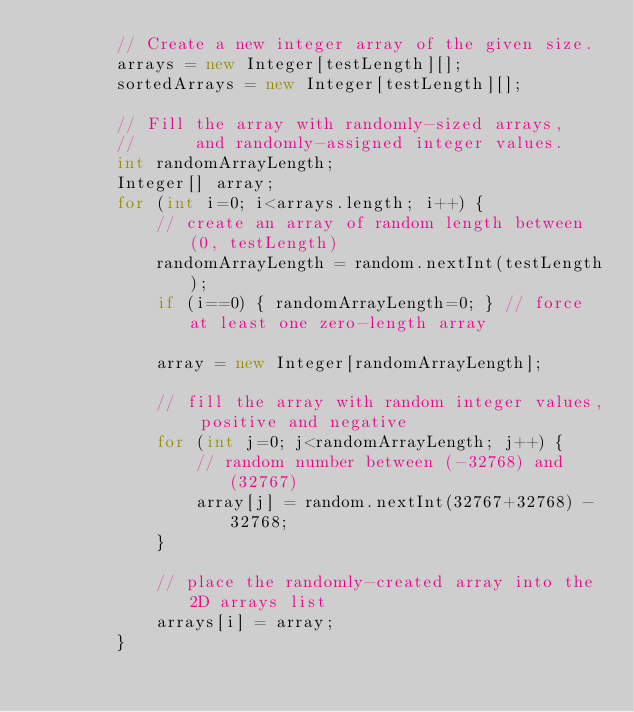<code> <loc_0><loc_0><loc_500><loc_500><_Java_>        // Create a new integer array of the given size.
        arrays = new Integer[testLength][]; 
        sortedArrays = new Integer[testLength][];
        
        // Fill the array with randomly-sized arrays,
        //      and randomly-assigned integer values.
        int randomArrayLength;
        Integer[] array;
        for (int i=0; i<arrays.length; i++) {
            // create an array of random length between (0, testLength)
            randomArrayLength = random.nextInt(testLength);
            if (i==0) { randomArrayLength=0; } // force at least one zero-length array
            
            array = new Integer[randomArrayLength];

            // fill the array with random integer values, positive and negative
            for (int j=0; j<randomArrayLength; j++) {
                // random number between (-32768) and (32767)
                array[j] = random.nextInt(32767+32768) - 32768;
            }
            
            // place the randomly-created array into the 2D arrays list
            arrays[i] = array;
        }
        </code> 